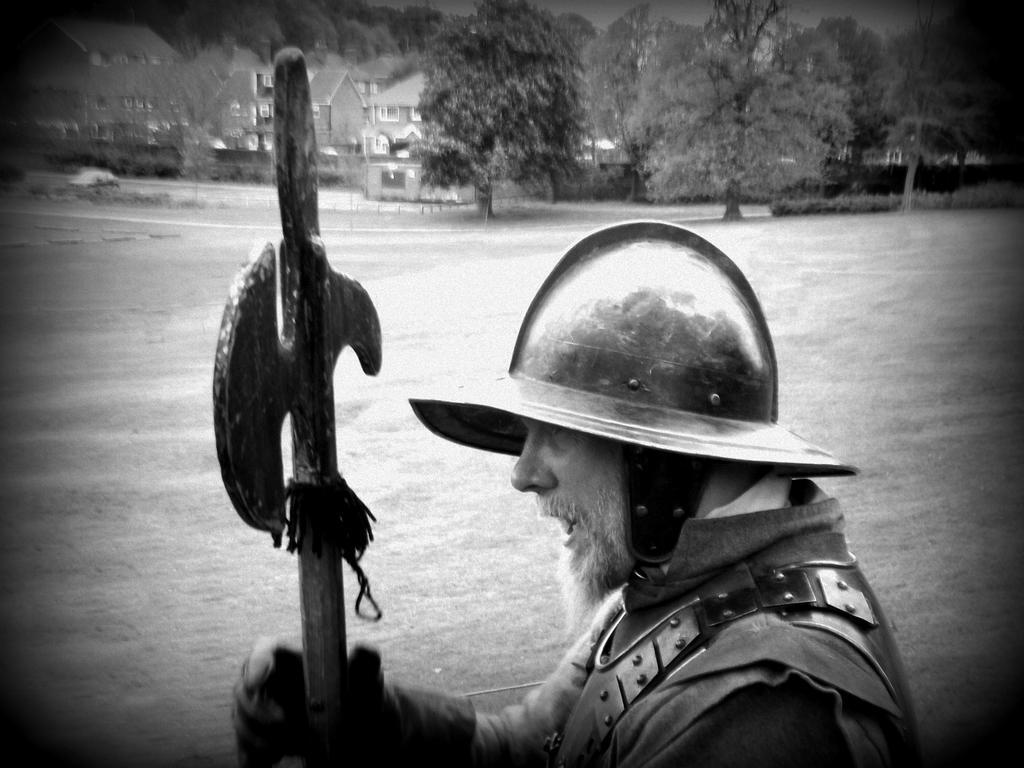Please provide a concise description of this image. In the middle of the image a man is standing and holding an axe. Behind him there is grass. At the top of the image there are some trees and buildings and there is a vehicle. 